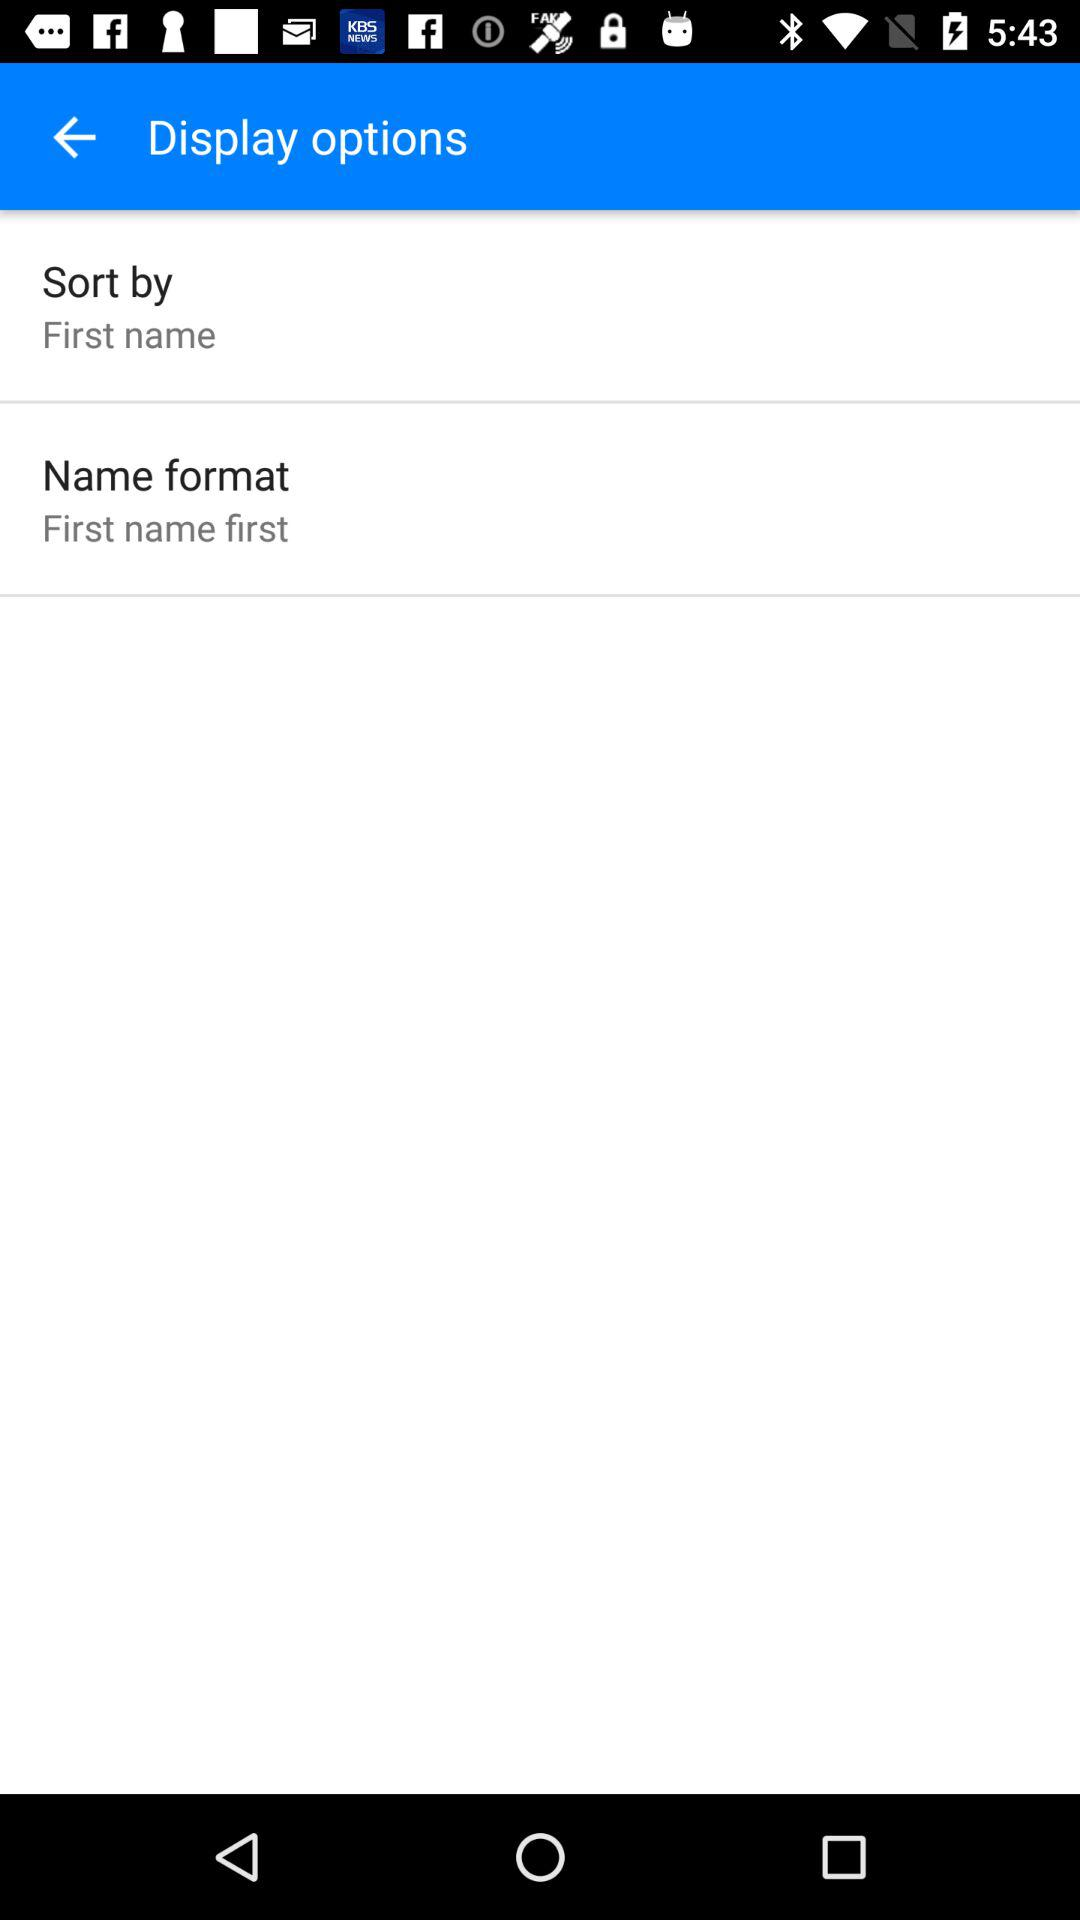What is the selected setting for "Sort by"? The selected setting for "Sort by" is "First name". 